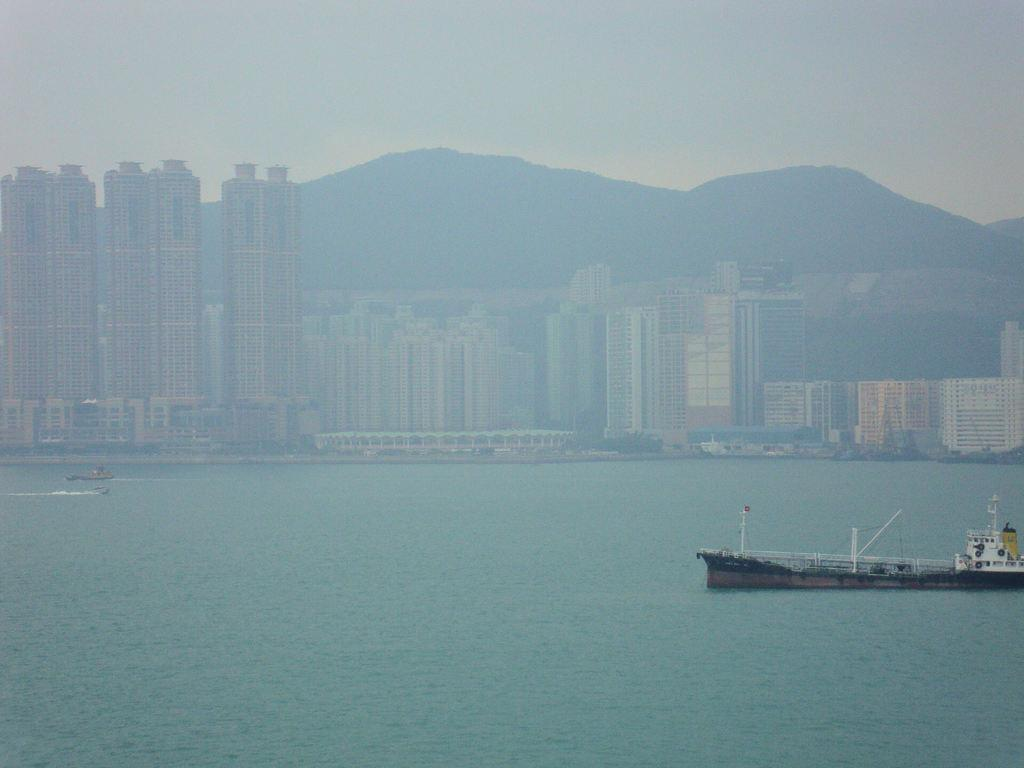What type of vehicles are in the image? There are boats in the image. Where are the boats located? The boats are on the water. What can be seen in the background of the image? There are buildings, mountains, and the sky visible in the background of the image. What type of chess piece is depicted on the boats in the image? There is no chess piece present on the boats in the image. Can you tell me the name of the son who is sailing one of the boats in the image? There is no information about a son sailing one of the boats in the image. 